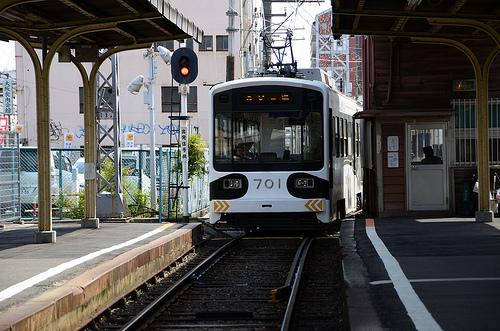What is happening with the train in the image, and who is interacting with it? A train is entering the station while a person stands by the door on a platform, and sunlight reflects on the train platform. Describe the vehicle present in the scene and its surroundings. A black and white train with number 701 is entering the station, with front headlights on, on tracks with wooden slats amidst a platform with several objects. Identify elements that add character or charm to the scene in the image. The front of the train's design, blue graffiti on the side of a building, and a straight white line on the train platform contribute to the image's character. Explain some details about the platform and its features in the image. The platform has a chain link fence, wooden slats between train tracks, a shade, a door and window, white signs, and sunlight reflecting on it. Mention some decorative aspects found within the image. There is blue graffiti on the side of a building, white bars on a window, two white signs on a wall, and a white line painted on the train platform. What are some safety-related items and precautions seen in the image? There's a yellow warning light and line near the train track, white line painted on the train platform, and a metal chain link fence around a parking lot. Mention the main colors and prominent objects in the image. The train is black and white, there is a yellow warning light, wooden slats between tracks, and a white door with a glass window on the platform. Identify the key elements related to transportation in the image. A train with the number 701, train tracks in the ground, wooden slats between tracks, and a traffic light for the train are present in the image. Provide a brief summary of the scene captured in the image. A black and white train is passing by a platform with various elements such as a chain link fence, wooden beams, and a person standing at a white door. Describe the lighting elements visible in the image. There's a traffic light for the train, the front headlights of the black and white train are on, and sunlight is reflecting on the train platform. 